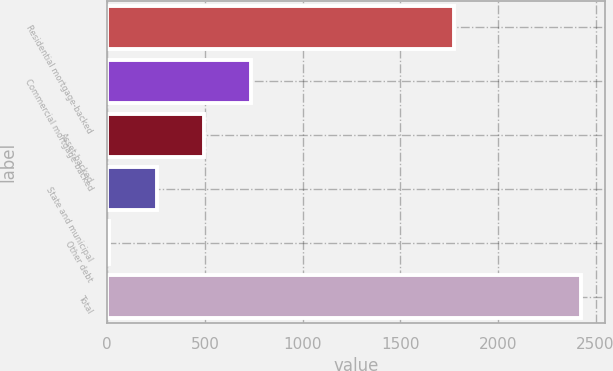Convert chart. <chart><loc_0><loc_0><loc_500><loc_500><bar_chart><fcel>Residential mortgage-backed<fcel>Commercial mortgage-backed<fcel>Asset-backed<fcel>State and municipal<fcel>Other debt<fcel>Total<nl><fcel>1775<fcel>735.5<fcel>494<fcel>252.5<fcel>11<fcel>2426<nl></chart> 